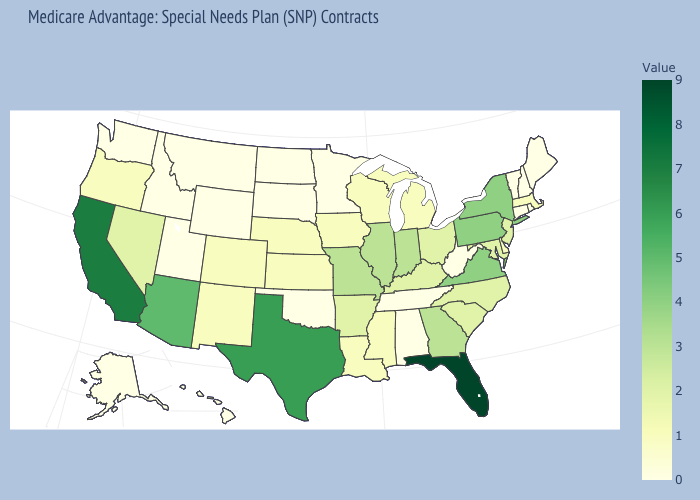Which states hav the highest value in the Northeast?
Quick response, please. New York, Pennsylvania. Which states have the lowest value in the USA?
Keep it brief. Alaska, Alabama, Connecticut, Hawaii, Idaho, Maine, Minnesota, Montana, North Dakota, New Hampshire, Oklahoma, Rhode Island, South Dakota, Tennessee, Utah, Vermont, Washington, West Virginia, Wyoming. 